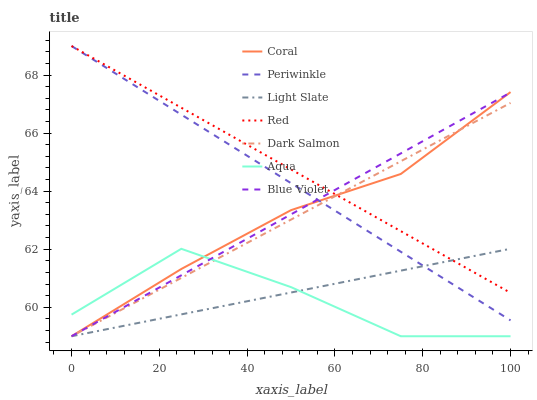Does Aqua have the minimum area under the curve?
Answer yes or no. Yes. Does Red have the maximum area under the curve?
Answer yes or no. Yes. Does Coral have the minimum area under the curve?
Answer yes or no. No. Does Coral have the maximum area under the curve?
Answer yes or no. No. Is Light Slate the smoothest?
Answer yes or no. Yes. Is Aqua the roughest?
Answer yes or no. Yes. Is Coral the smoothest?
Answer yes or no. No. Is Coral the roughest?
Answer yes or no. No. Does Periwinkle have the lowest value?
Answer yes or no. No. Does Coral have the highest value?
Answer yes or no. No. Is Aqua less than Red?
Answer yes or no. Yes. Is Red greater than Aqua?
Answer yes or no. Yes. Does Aqua intersect Red?
Answer yes or no. No. 